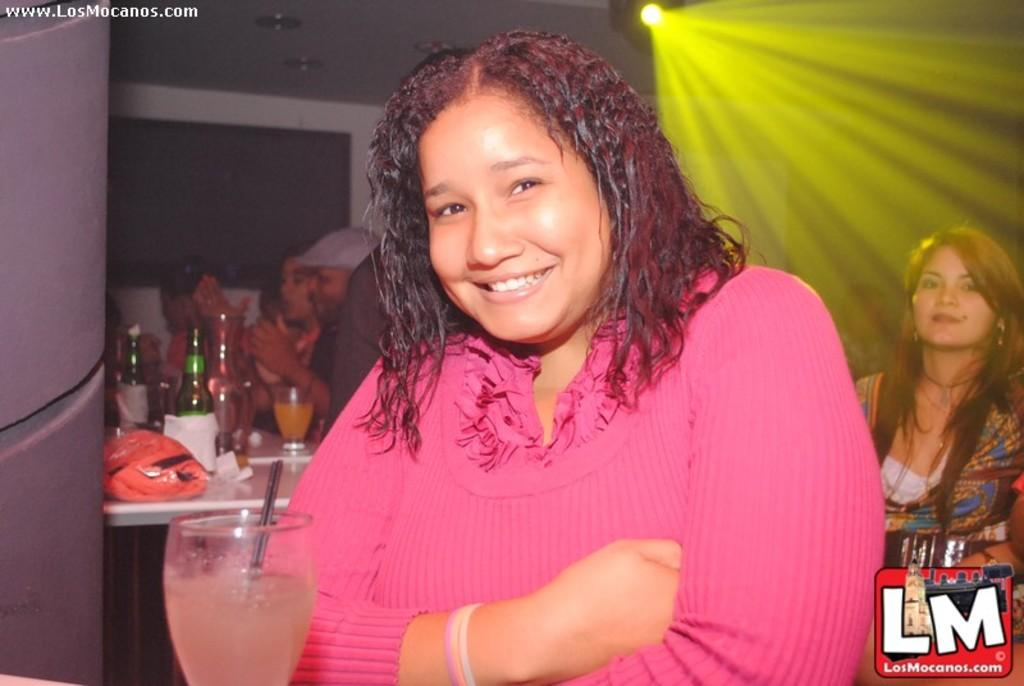Who is the main subject in the image? There is a woman in the image. What is in front of the woman? The woman is in front of a glass. Where are the people sitting in relation to the woman? The people are sitting behind the woman. What are the people sitting on or at? The people are sitting at a table. What items can be seen on the table? There are bottles and glasses on the table. What type of cherries are being used to make the coil in the image? There are no cherries or coils present in the image. What is the topic of the argument taking place between the people in the image? There is no argument taking place in the image; the people are sitting quietly at a table. 